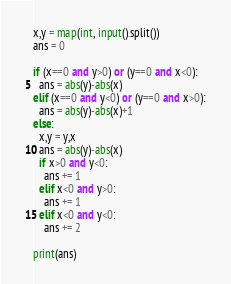<code> <loc_0><loc_0><loc_500><loc_500><_Python_>x,y = map(int, input().split())
ans = 0

if (x==0 and y>0) or (y==0 and x<0):
  ans = abs(y)-abs(x)
elif (x==0 and y<0) or (y==0 and x>0):
  ans = abs(y)-abs(x)+1
else:
  x,y = y,x
  ans = abs(y)-abs(x)
  if x>0 and y<0:
    ans += 1
  elif x<0 and y>0:
    ans += 1
  elif x<0 and y<0:
    ans += 2

print(ans)


</code> 